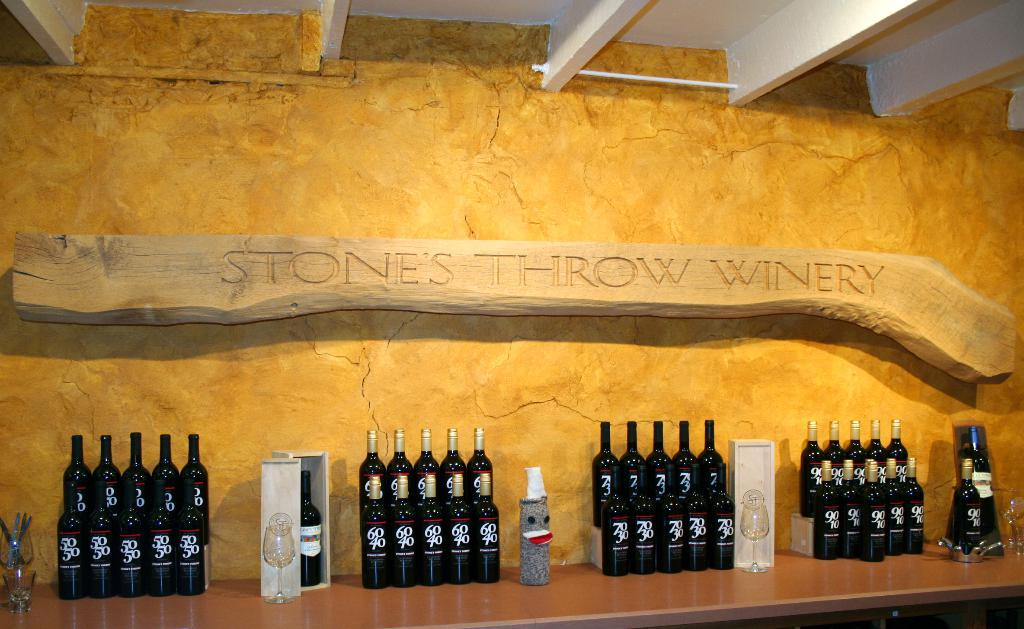Provide a one-sentence caption for the provided image. Stone throw winery is displaying their wines on a wooden counter behind a yellow background. 